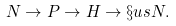Convert formula to latex. <formula><loc_0><loc_0><loc_500><loc_500>N \to P \to H \to \S u s { N } .</formula> 